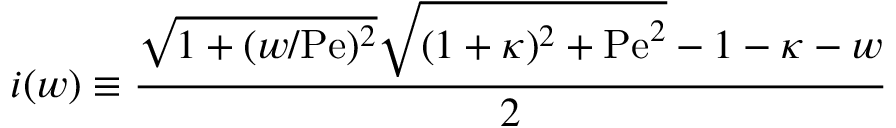<formula> <loc_0><loc_0><loc_500><loc_500>i ( w ) \equiv \frac { \sqrt { 1 + ( w / P e ) ^ { 2 } } \sqrt { ( 1 + \kappa ) ^ { 2 } + P e ^ { 2 } } - 1 - \kappa - w } { 2 }</formula> 